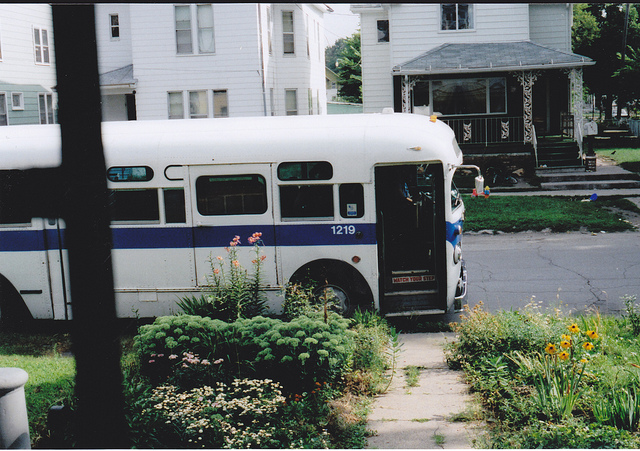Read all the text in this image. 1219 